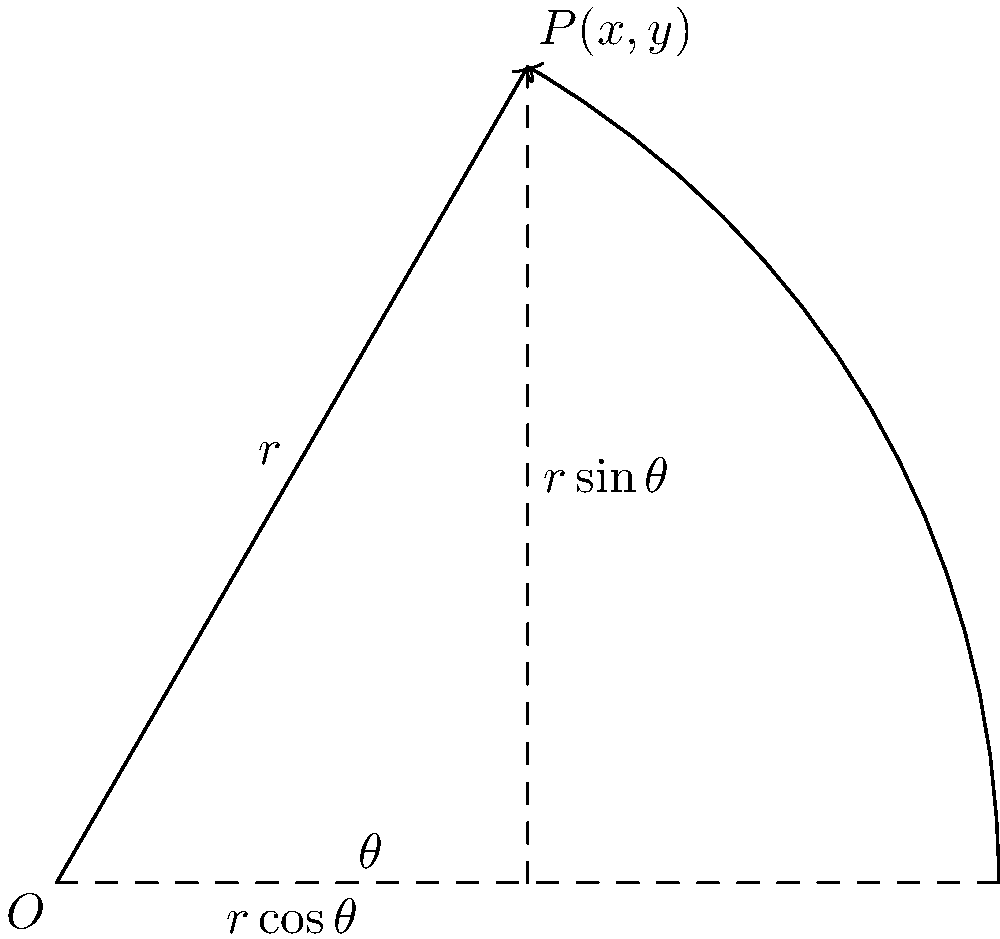Given a point $P$ in polar coordinates $(r,\theta)$, where $r=4$ and $\theta=\frac{\pi}{3}$, determine its Cartesian coordinates $(x,y)$. Express your answer as a pair of exact values, not decimal approximations. To convert from polar coordinates $(r,\theta)$ to Cartesian coordinates $(x,y)$, we use the following formulas:

1. $x = r \cos(\theta)$
2. $y = r \sin(\theta)$

Given:
- $r = 4$
- $\theta = \frac{\pi}{3}$

Step 1: Calculate $x$
$x = r \cos(\theta) = 4 \cos(\frac{\pi}{3})$
$\cos(\frac{\pi}{3}) = \frac{1}{2}$
Therefore, $x = 4 \cdot \frac{1}{2} = 2$

Step 2: Calculate $y$
$y = r \sin(\theta) = 4 \sin(\frac{\pi}{3})$
$\sin(\frac{\pi}{3}) = \frac{\sqrt{3}}{2}$
Therefore, $y = 4 \cdot \frac{\sqrt{3}}{2} = 2\sqrt{3}$

The Cartesian coordinates of point $P$ are $(2, 2\sqrt{3})$.
Answer: $(2, 2\sqrt{3})$ 